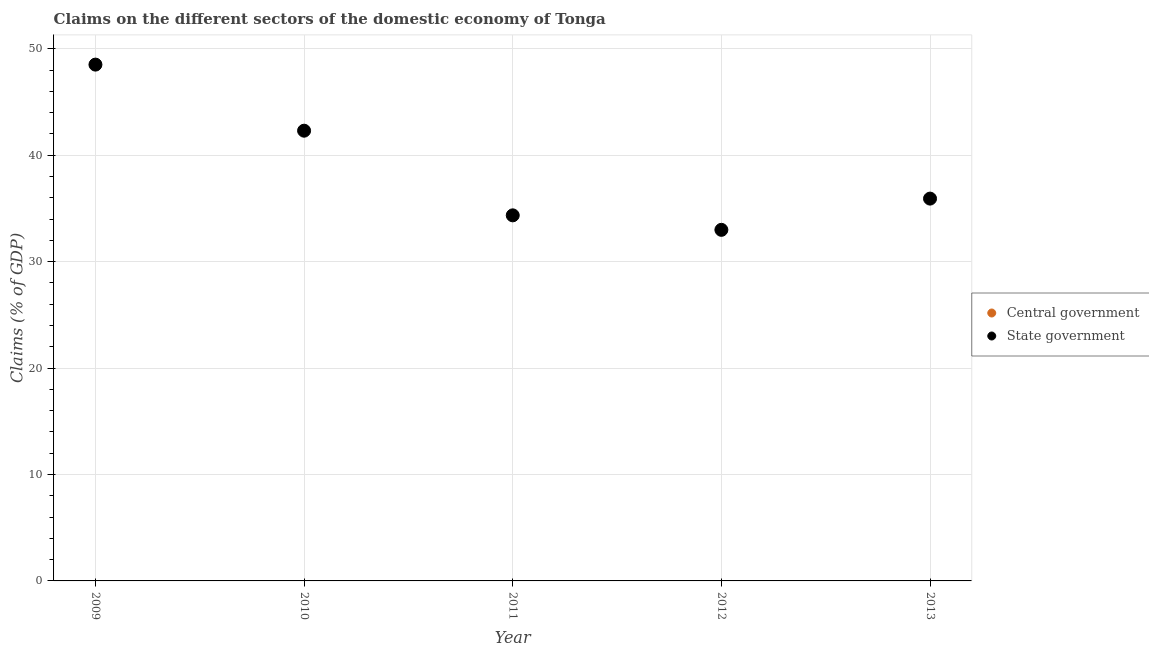How many different coloured dotlines are there?
Provide a short and direct response. 1. What is the claims on state government in 2011?
Provide a succinct answer. 34.35. Across all years, what is the maximum claims on state government?
Your answer should be very brief. 48.51. Across all years, what is the minimum claims on state government?
Ensure brevity in your answer.  32.99. What is the total claims on central government in the graph?
Provide a short and direct response. 0. What is the difference between the claims on state government in 2009 and that in 2012?
Provide a short and direct response. 15.52. What is the difference between the claims on state government in 2012 and the claims on central government in 2009?
Your answer should be compact. 32.99. What is the average claims on state government per year?
Make the answer very short. 38.81. In how many years, is the claims on state government greater than 20 %?
Your response must be concise. 5. What is the ratio of the claims on state government in 2009 to that in 2012?
Ensure brevity in your answer.  1.47. Is the claims on state government in 2009 less than that in 2011?
Your response must be concise. No. What is the difference between the highest and the second highest claims on state government?
Keep it short and to the point. 6.21. What is the difference between the highest and the lowest claims on state government?
Your response must be concise. 15.52. In how many years, is the claims on central government greater than the average claims on central government taken over all years?
Offer a terse response. 0. Is the sum of the claims on state government in 2010 and 2012 greater than the maximum claims on central government across all years?
Your answer should be very brief. Yes. How many dotlines are there?
Offer a very short reply. 1. How many years are there in the graph?
Provide a short and direct response. 5. Does the graph contain any zero values?
Provide a succinct answer. Yes. How many legend labels are there?
Provide a short and direct response. 2. How are the legend labels stacked?
Give a very brief answer. Vertical. What is the title of the graph?
Provide a succinct answer. Claims on the different sectors of the domestic economy of Tonga. Does "Old" appear as one of the legend labels in the graph?
Make the answer very short. No. What is the label or title of the X-axis?
Keep it short and to the point. Year. What is the label or title of the Y-axis?
Your answer should be compact. Claims (% of GDP). What is the Claims (% of GDP) in State government in 2009?
Provide a succinct answer. 48.51. What is the Claims (% of GDP) of State government in 2010?
Offer a very short reply. 42.3. What is the Claims (% of GDP) of State government in 2011?
Give a very brief answer. 34.35. What is the Claims (% of GDP) of State government in 2012?
Make the answer very short. 32.99. What is the Claims (% of GDP) in State government in 2013?
Offer a very short reply. 35.92. Across all years, what is the maximum Claims (% of GDP) in State government?
Offer a terse response. 48.51. Across all years, what is the minimum Claims (% of GDP) in State government?
Ensure brevity in your answer.  32.99. What is the total Claims (% of GDP) of Central government in the graph?
Give a very brief answer. 0. What is the total Claims (% of GDP) in State government in the graph?
Your answer should be very brief. 194.07. What is the difference between the Claims (% of GDP) in State government in 2009 and that in 2010?
Keep it short and to the point. 6.21. What is the difference between the Claims (% of GDP) of State government in 2009 and that in 2011?
Offer a terse response. 14.16. What is the difference between the Claims (% of GDP) of State government in 2009 and that in 2012?
Offer a very short reply. 15.52. What is the difference between the Claims (% of GDP) of State government in 2009 and that in 2013?
Make the answer very short. 12.59. What is the difference between the Claims (% of GDP) of State government in 2010 and that in 2011?
Provide a succinct answer. 7.95. What is the difference between the Claims (% of GDP) of State government in 2010 and that in 2012?
Make the answer very short. 9.32. What is the difference between the Claims (% of GDP) of State government in 2010 and that in 2013?
Your answer should be very brief. 6.38. What is the difference between the Claims (% of GDP) in State government in 2011 and that in 2012?
Your response must be concise. 1.36. What is the difference between the Claims (% of GDP) of State government in 2011 and that in 2013?
Your response must be concise. -1.57. What is the difference between the Claims (% of GDP) of State government in 2012 and that in 2013?
Give a very brief answer. -2.93. What is the average Claims (% of GDP) in State government per year?
Your answer should be compact. 38.81. What is the ratio of the Claims (% of GDP) of State government in 2009 to that in 2010?
Ensure brevity in your answer.  1.15. What is the ratio of the Claims (% of GDP) in State government in 2009 to that in 2011?
Provide a short and direct response. 1.41. What is the ratio of the Claims (% of GDP) of State government in 2009 to that in 2012?
Your answer should be very brief. 1.47. What is the ratio of the Claims (% of GDP) of State government in 2009 to that in 2013?
Your response must be concise. 1.35. What is the ratio of the Claims (% of GDP) of State government in 2010 to that in 2011?
Give a very brief answer. 1.23. What is the ratio of the Claims (% of GDP) of State government in 2010 to that in 2012?
Your answer should be compact. 1.28. What is the ratio of the Claims (% of GDP) of State government in 2010 to that in 2013?
Make the answer very short. 1.18. What is the ratio of the Claims (% of GDP) in State government in 2011 to that in 2012?
Provide a short and direct response. 1.04. What is the ratio of the Claims (% of GDP) in State government in 2011 to that in 2013?
Make the answer very short. 0.96. What is the ratio of the Claims (% of GDP) of State government in 2012 to that in 2013?
Provide a short and direct response. 0.92. What is the difference between the highest and the second highest Claims (% of GDP) of State government?
Your answer should be very brief. 6.21. What is the difference between the highest and the lowest Claims (% of GDP) of State government?
Offer a very short reply. 15.52. 